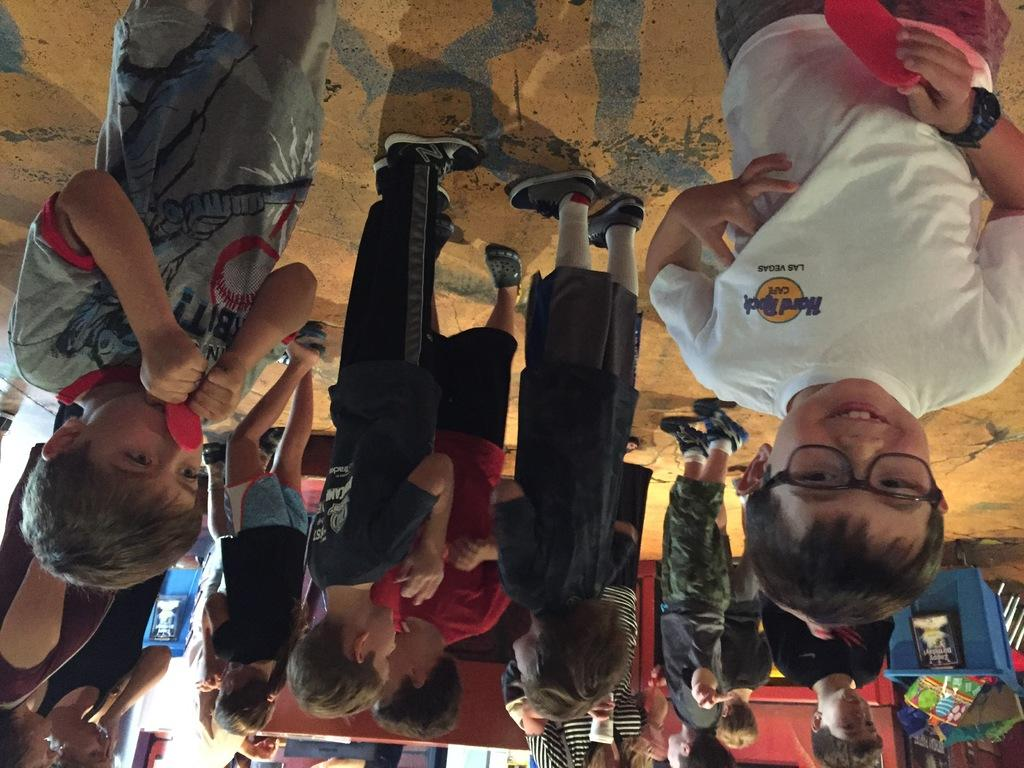What is happening in the image? There are persons standing in the image. Where are the persons located in the image? They are located at the bottom right of the image. What else can be seen in the image besides the persons? There is a basket visible in the image. What type of badge is being worn by the persons in the image? There is no badge visible in the image. How many bricks are present in the image? There is no reference to bricks in the image, so it is not possible to determine their number. 